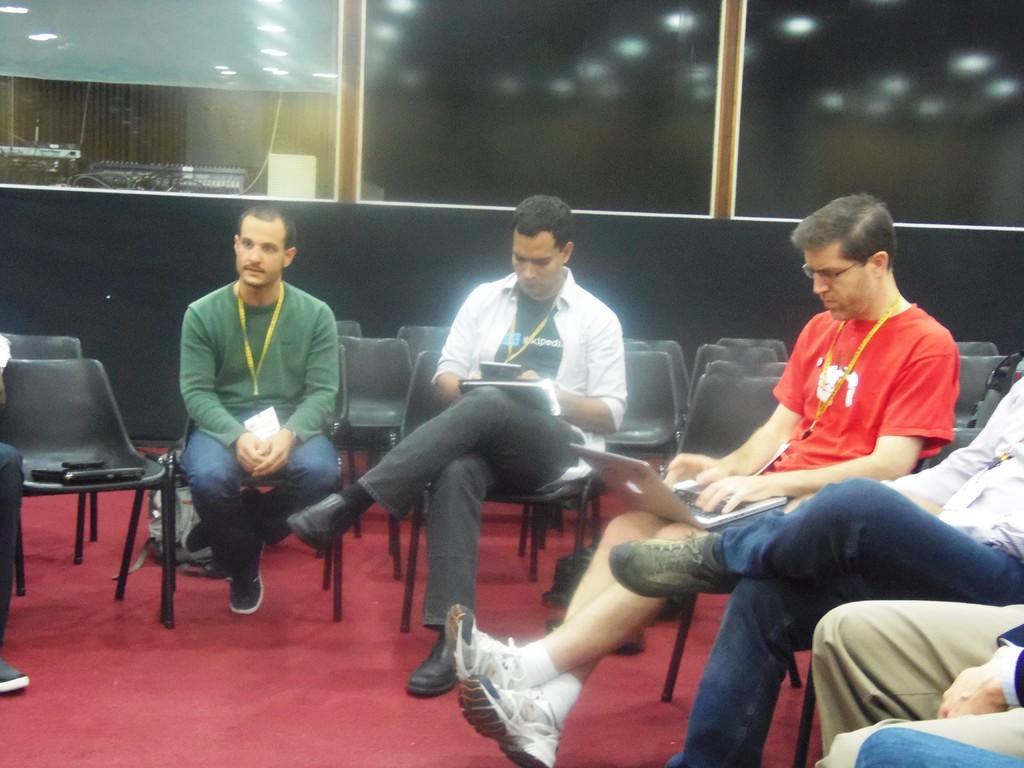Could you give a brief overview of what you see in this image? In this image there are people sitting on the chairs. Behind them there are empty chairs. In the background of the image there are glass doors through which we can see some musical instruments. At the top of the image there are lights. At the bottom of the image there is a mat on the floor. 